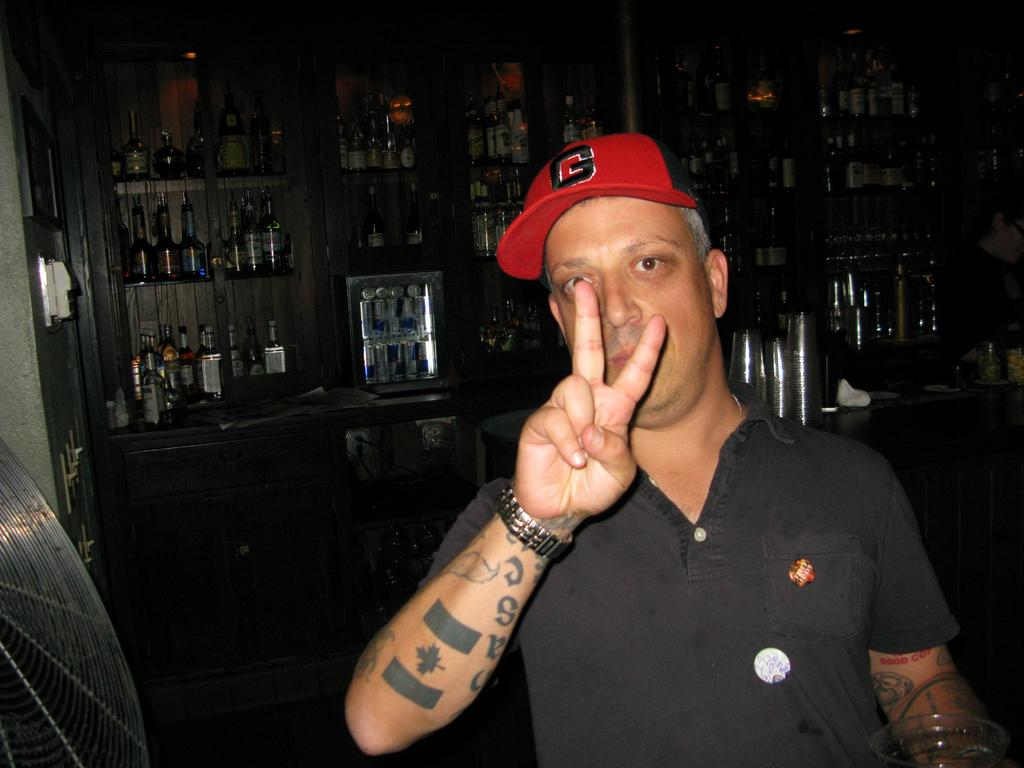What is the main subject of the image? There is a man in the image. Can you describe the man's clothing? The man is wearing a black t-shirt and a cap. Where is the man positioned in the image? The man is standing on the right side of the image. What can be seen on the shelves in the image? There are bottles and cans on the shelves. What other object is present in the image? There is a switch board in the image. What type of farm animals can be seen running in the image? There are no farm animals or any indication of running in the image. 